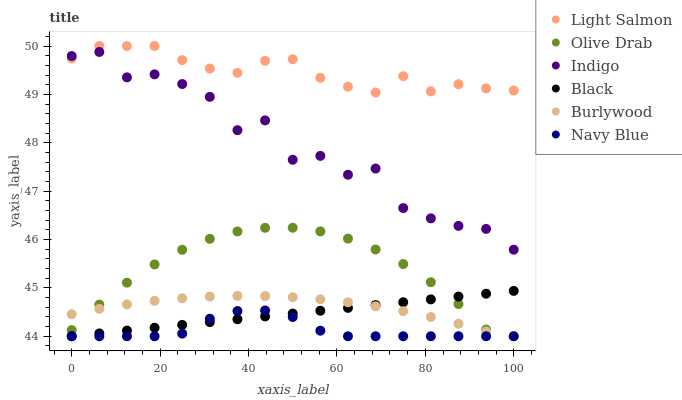Does Navy Blue have the minimum area under the curve?
Answer yes or no. Yes. Does Light Salmon have the maximum area under the curve?
Answer yes or no. Yes. Does Indigo have the minimum area under the curve?
Answer yes or no. No. Does Indigo have the maximum area under the curve?
Answer yes or no. No. Is Black the smoothest?
Answer yes or no. Yes. Is Indigo the roughest?
Answer yes or no. Yes. Is Burlywood the smoothest?
Answer yes or no. No. Is Burlywood the roughest?
Answer yes or no. No. Does Burlywood have the lowest value?
Answer yes or no. Yes. Does Indigo have the lowest value?
Answer yes or no. No. Does Light Salmon have the highest value?
Answer yes or no. Yes. Does Indigo have the highest value?
Answer yes or no. No. Is Black less than Indigo?
Answer yes or no. Yes. Is Light Salmon greater than Navy Blue?
Answer yes or no. Yes. Does Navy Blue intersect Burlywood?
Answer yes or no. Yes. Is Navy Blue less than Burlywood?
Answer yes or no. No. Is Navy Blue greater than Burlywood?
Answer yes or no. No. Does Black intersect Indigo?
Answer yes or no. No. 